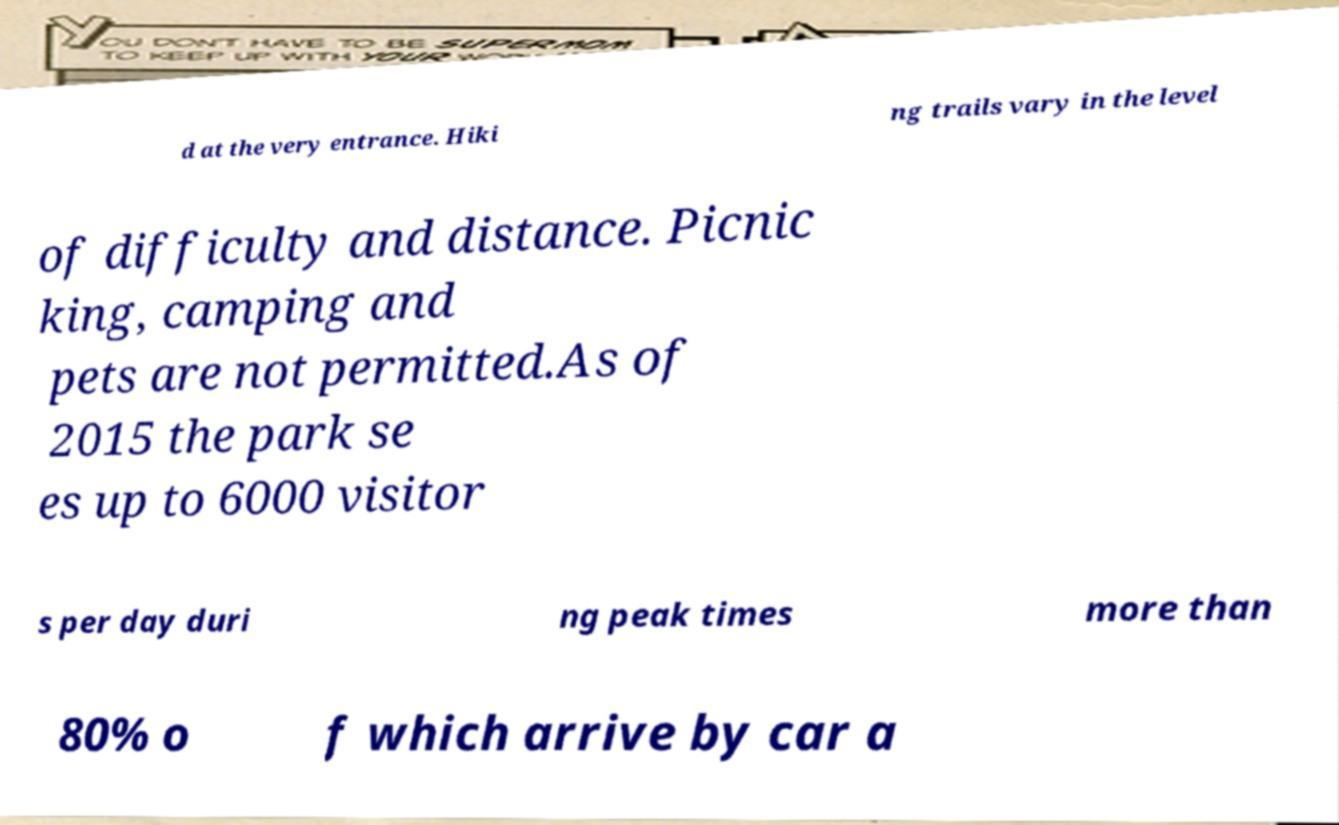There's text embedded in this image that I need extracted. Can you transcribe it verbatim? d at the very entrance. Hiki ng trails vary in the level of difficulty and distance. Picnic king, camping and pets are not permitted.As of 2015 the park se es up to 6000 visitor s per day duri ng peak times more than 80% o f which arrive by car a 